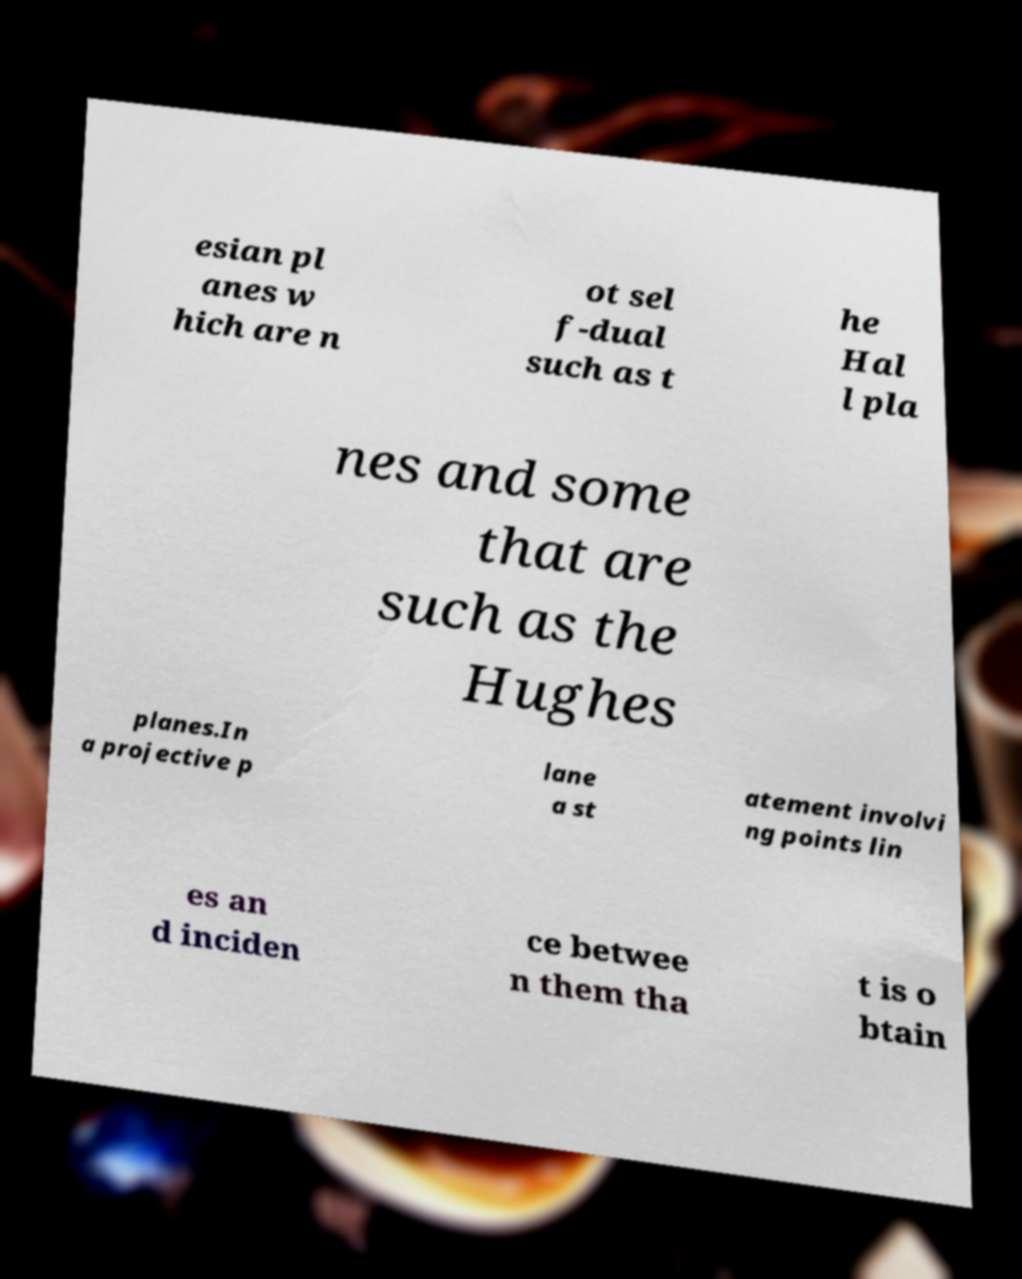What messages or text are displayed in this image? I need them in a readable, typed format. esian pl anes w hich are n ot sel f-dual such as t he Hal l pla nes and some that are such as the Hughes planes.In a projective p lane a st atement involvi ng points lin es an d inciden ce betwee n them tha t is o btain 